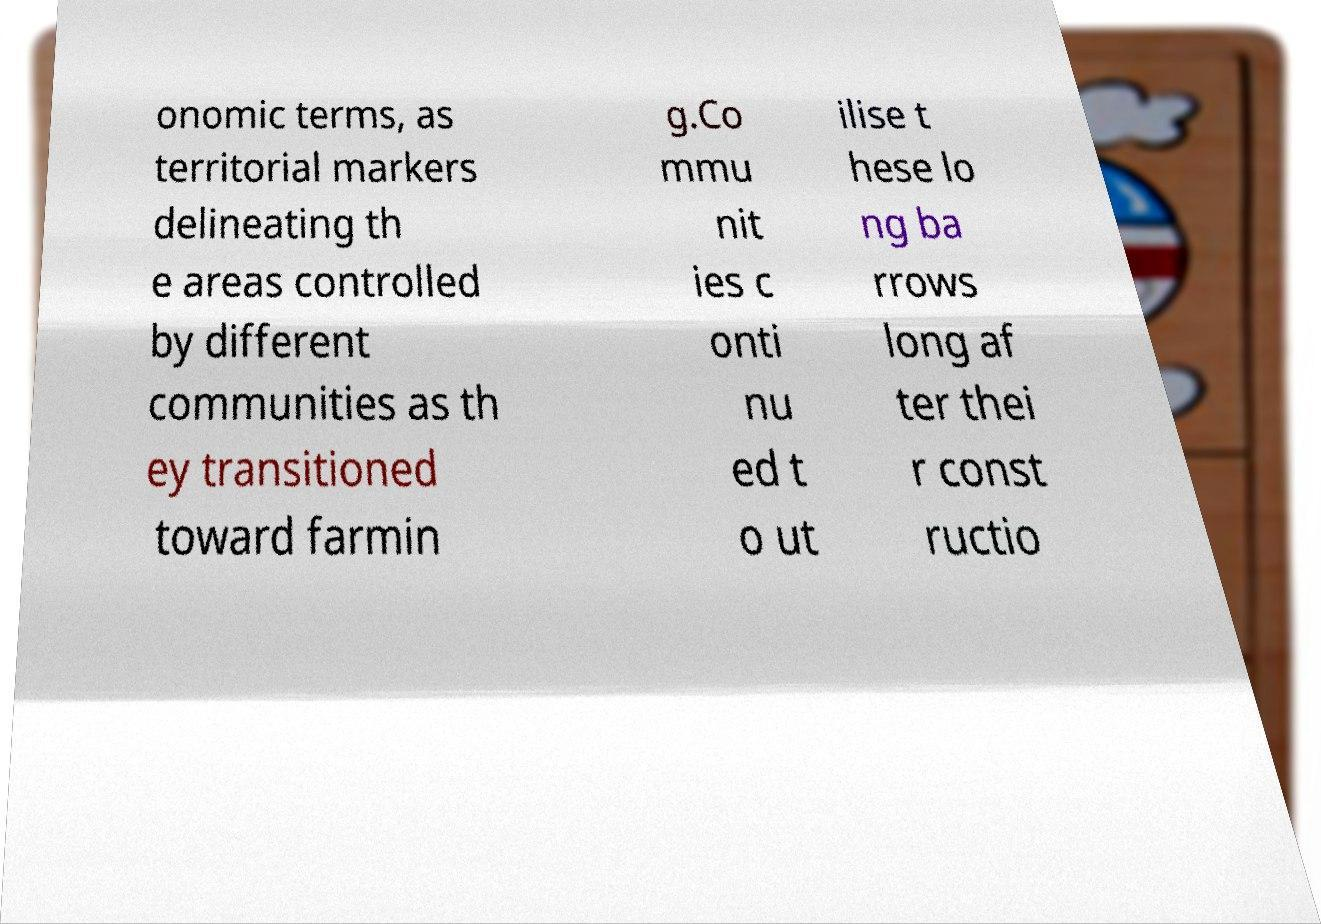Could you assist in decoding the text presented in this image and type it out clearly? onomic terms, as territorial markers delineating th e areas controlled by different communities as th ey transitioned toward farmin g.Co mmu nit ies c onti nu ed t o ut ilise t hese lo ng ba rrows long af ter thei r const ructio 